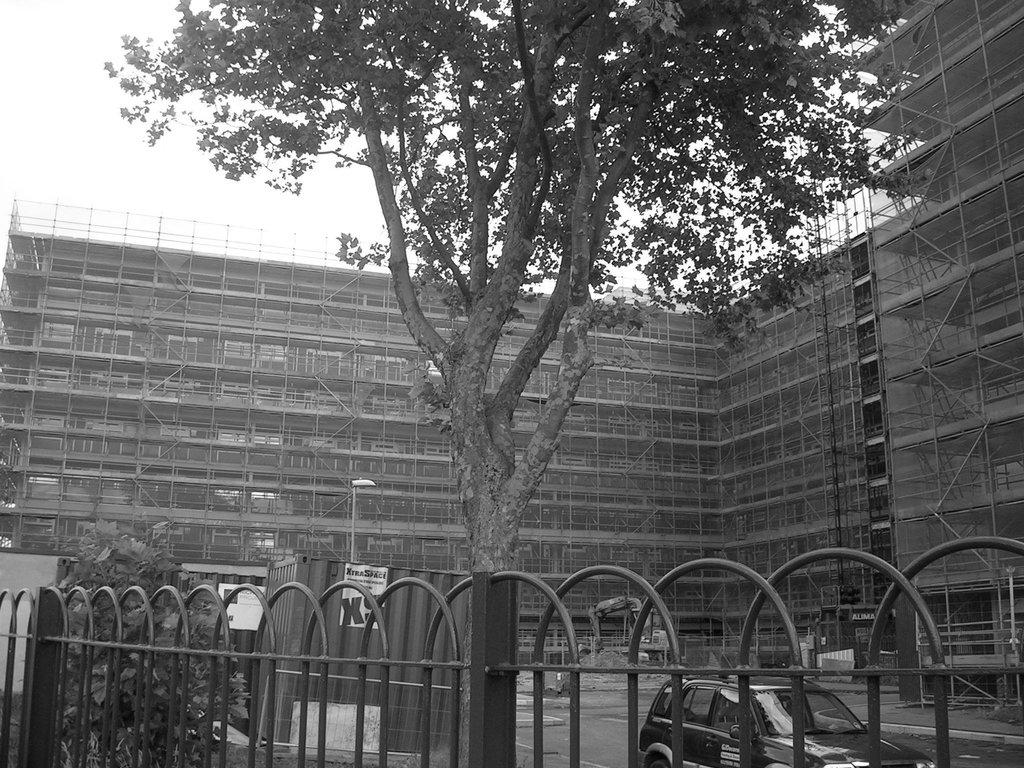What type of structures can be seen in the image? There are buildings in the image. What else is present in the image besides the buildings? There is a vehicle, a tree, a plant, a fence, and the sky is visible in the image. What is the color scheme of the image? The image is black and white in color. Can you tell me what book the pet is reading in the image? There is no pet or book present in the image. What type of spade is being used to dig in the plant in the image? There is no spade or digging activity present in the image. 